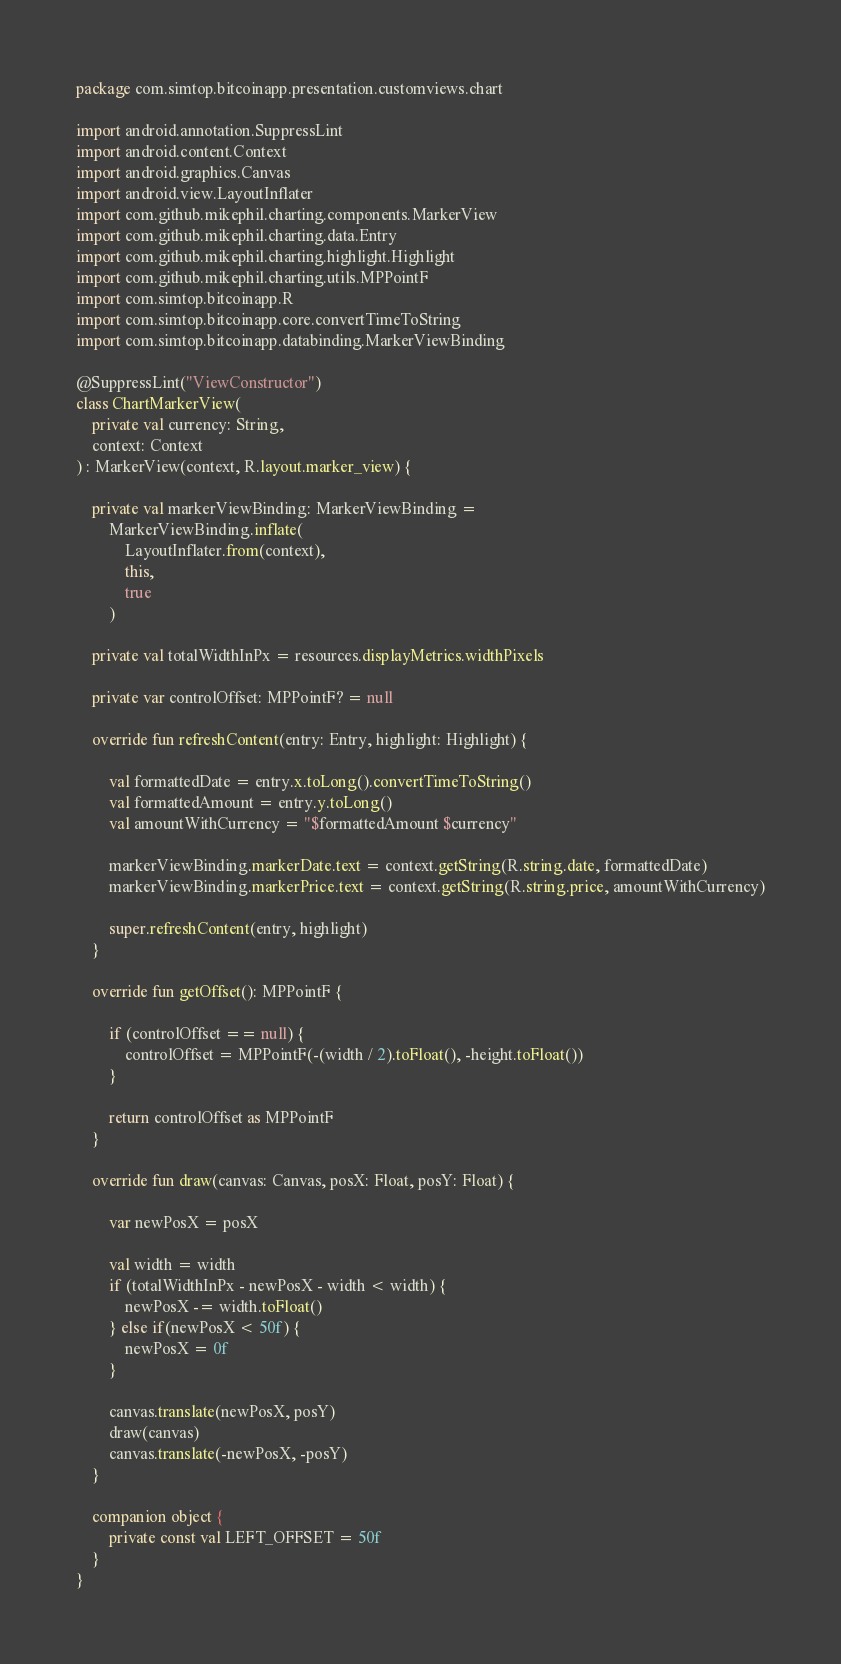<code> <loc_0><loc_0><loc_500><loc_500><_Kotlin_>package com.simtop.bitcoinapp.presentation.customviews.chart

import android.annotation.SuppressLint
import android.content.Context
import android.graphics.Canvas
import android.view.LayoutInflater
import com.github.mikephil.charting.components.MarkerView
import com.github.mikephil.charting.data.Entry
import com.github.mikephil.charting.highlight.Highlight
import com.github.mikephil.charting.utils.MPPointF
import com.simtop.bitcoinapp.R
import com.simtop.bitcoinapp.core.convertTimeToString
import com.simtop.bitcoinapp.databinding.MarkerViewBinding

@SuppressLint("ViewConstructor")
class ChartMarkerView(
    private val currency: String,
    context: Context
) : MarkerView(context, R.layout.marker_view) {

    private val markerViewBinding: MarkerViewBinding =
        MarkerViewBinding.inflate(
            LayoutInflater.from(context),
            this,
            true
        )

    private val totalWidthInPx = resources.displayMetrics.widthPixels

    private var controlOffset: MPPointF? = null

    override fun refreshContent(entry: Entry, highlight: Highlight) {

        val formattedDate = entry.x.toLong().convertTimeToString()
        val formattedAmount = entry.y.toLong()
        val amountWithCurrency = "$formattedAmount $currency"

        markerViewBinding.markerDate.text = context.getString(R.string.date, formattedDate)
        markerViewBinding.markerPrice.text = context.getString(R.string.price, amountWithCurrency)

        super.refreshContent(entry, highlight)
    }

    override fun getOffset(): MPPointF {

        if (controlOffset == null) {
            controlOffset = MPPointF(-(width / 2).toFloat(), -height.toFloat())
        }

        return controlOffset as MPPointF
    }

    override fun draw(canvas: Canvas, posX: Float, posY: Float) {

        var newPosX = posX

        val width = width
        if (totalWidthInPx - newPosX - width < width) {
            newPosX -= width.toFloat()
        } else if(newPosX < 50f) {
            newPosX = 0f
        }

        canvas.translate(newPosX, posY)
        draw(canvas)
        canvas.translate(-newPosX, -posY)
    }

    companion object {
        private const val LEFT_OFFSET = 50f
    }
}</code> 